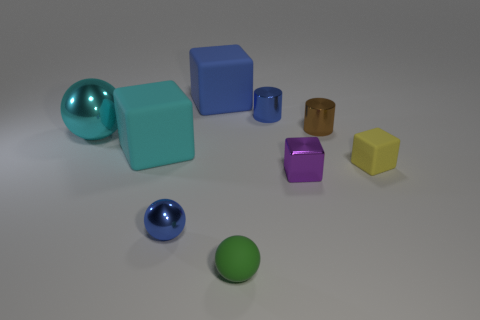Is there any other thing that has the same color as the big metallic sphere?
Your answer should be compact. Yes. There is a metallic thing that is the same color as the tiny metal ball; what is its size?
Offer a terse response. Small. Are there any other objects that have the same color as the big metal object?
Make the answer very short. Yes. There is a large metallic thing; is it the same color as the matte cube that is on the right side of the blue matte cube?
Your answer should be very brief. No. The tiny metal block is what color?
Your answer should be very brief. Purple. There is a tiny sphere that is to the left of the tiny green rubber object; what is its material?
Make the answer very short. Metal. There is a cyan object that is the same shape as the purple shiny thing; what is its size?
Your answer should be compact. Large. Are there fewer brown cylinders that are in front of the small yellow rubber thing than large blue metal things?
Your response must be concise. No. Are any brown metallic balls visible?
Provide a short and direct response. No. There is another small matte thing that is the same shape as the purple thing; what color is it?
Provide a succinct answer. Yellow. 